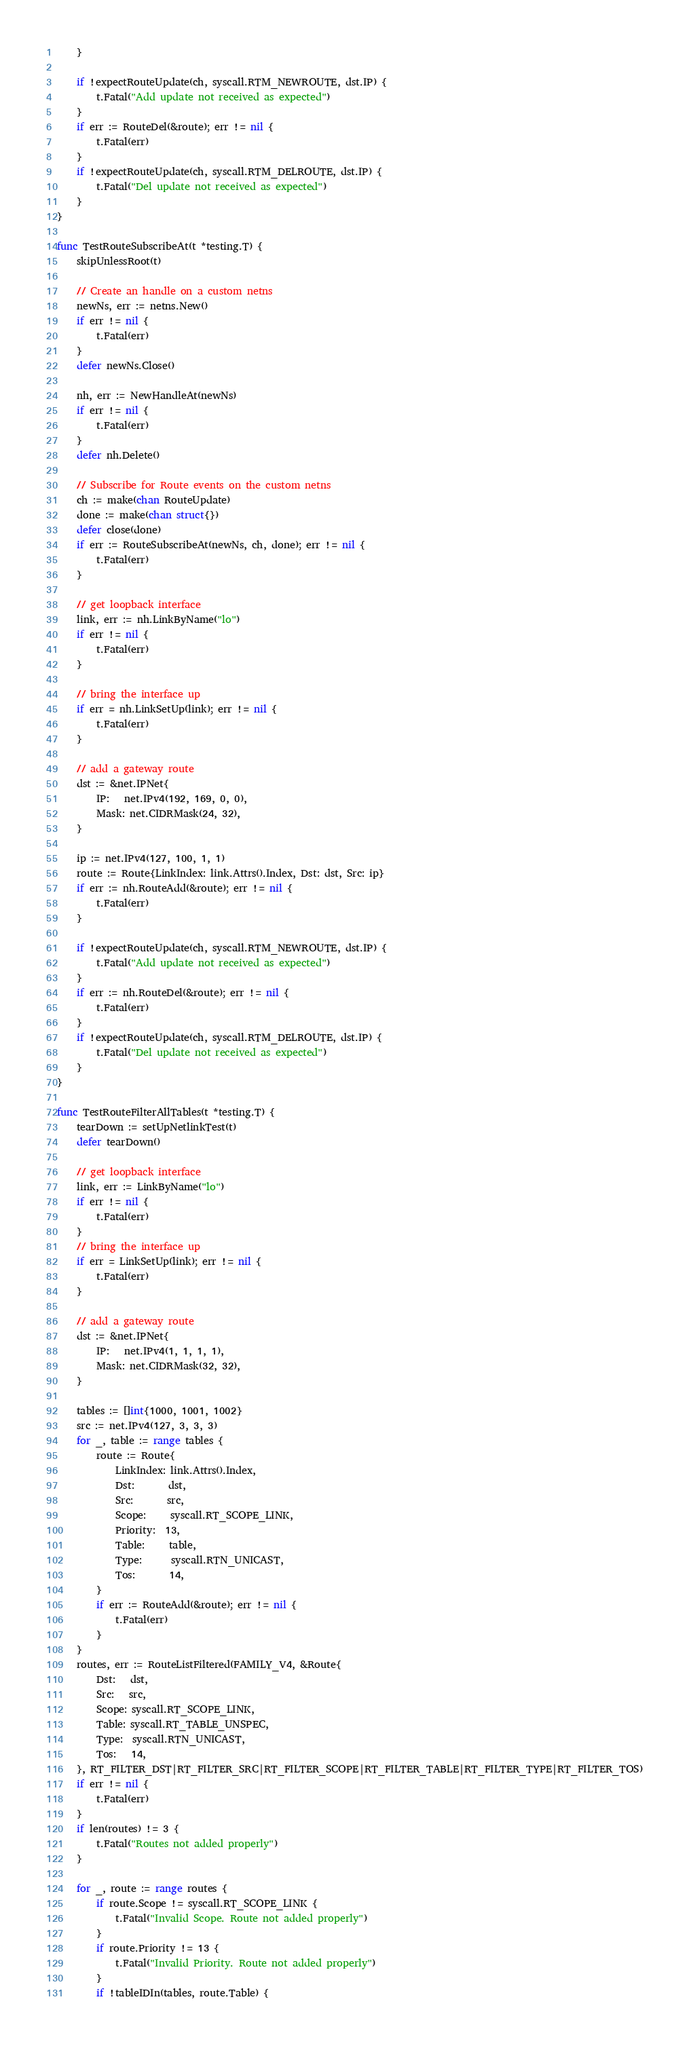<code> <loc_0><loc_0><loc_500><loc_500><_Go_>	}

	if !expectRouteUpdate(ch, syscall.RTM_NEWROUTE, dst.IP) {
		t.Fatal("Add update not received as expected")
	}
	if err := RouteDel(&route); err != nil {
		t.Fatal(err)
	}
	if !expectRouteUpdate(ch, syscall.RTM_DELROUTE, dst.IP) {
		t.Fatal("Del update not received as expected")
	}
}

func TestRouteSubscribeAt(t *testing.T) {
	skipUnlessRoot(t)

	// Create an handle on a custom netns
	newNs, err := netns.New()
	if err != nil {
		t.Fatal(err)
	}
	defer newNs.Close()

	nh, err := NewHandleAt(newNs)
	if err != nil {
		t.Fatal(err)
	}
	defer nh.Delete()

	// Subscribe for Route events on the custom netns
	ch := make(chan RouteUpdate)
	done := make(chan struct{})
	defer close(done)
	if err := RouteSubscribeAt(newNs, ch, done); err != nil {
		t.Fatal(err)
	}

	// get loopback interface
	link, err := nh.LinkByName("lo")
	if err != nil {
		t.Fatal(err)
	}

	// bring the interface up
	if err = nh.LinkSetUp(link); err != nil {
		t.Fatal(err)
	}

	// add a gateway route
	dst := &net.IPNet{
		IP:   net.IPv4(192, 169, 0, 0),
		Mask: net.CIDRMask(24, 32),
	}

	ip := net.IPv4(127, 100, 1, 1)
	route := Route{LinkIndex: link.Attrs().Index, Dst: dst, Src: ip}
	if err := nh.RouteAdd(&route); err != nil {
		t.Fatal(err)
	}

	if !expectRouteUpdate(ch, syscall.RTM_NEWROUTE, dst.IP) {
		t.Fatal("Add update not received as expected")
	}
	if err := nh.RouteDel(&route); err != nil {
		t.Fatal(err)
	}
	if !expectRouteUpdate(ch, syscall.RTM_DELROUTE, dst.IP) {
		t.Fatal("Del update not received as expected")
	}
}

func TestRouteFilterAllTables(t *testing.T) {
	tearDown := setUpNetlinkTest(t)
	defer tearDown()

	// get loopback interface
	link, err := LinkByName("lo")
	if err != nil {
		t.Fatal(err)
	}
	// bring the interface up
	if err = LinkSetUp(link); err != nil {
		t.Fatal(err)
	}

	// add a gateway route
	dst := &net.IPNet{
		IP:   net.IPv4(1, 1, 1, 1),
		Mask: net.CIDRMask(32, 32),
	}

	tables := []int{1000, 1001, 1002}
	src := net.IPv4(127, 3, 3, 3)
	for _, table := range tables {
		route := Route{
			LinkIndex: link.Attrs().Index,
			Dst:       dst,
			Src:       src,
			Scope:     syscall.RT_SCOPE_LINK,
			Priority:  13,
			Table:     table,
			Type:      syscall.RTN_UNICAST,
			Tos:       14,
		}
		if err := RouteAdd(&route); err != nil {
			t.Fatal(err)
		}
	}
	routes, err := RouteListFiltered(FAMILY_V4, &Route{
		Dst:   dst,
		Src:   src,
		Scope: syscall.RT_SCOPE_LINK,
		Table: syscall.RT_TABLE_UNSPEC,
		Type:  syscall.RTN_UNICAST,
		Tos:   14,
	}, RT_FILTER_DST|RT_FILTER_SRC|RT_FILTER_SCOPE|RT_FILTER_TABLE|RT_FILTER_TYPE|RT_FILTER_TOS)
	if err != nil {
		t.Fatal(err)
	}
	if len(routes) != 3 {
		t.Fatal("Routes not added properly")
	}

	for _, route := range routes {
		if route.Scope != syscall.RT_SCOPE_LINK {
			t.Fatal("Invalid Scope. Route not added properly")
		}
		if route.Priority != 13 {
			t.Fatal("Invalid Priority. Route not added properly")
		}
		if !tableIDIn(tables, route.Table) {</code> 